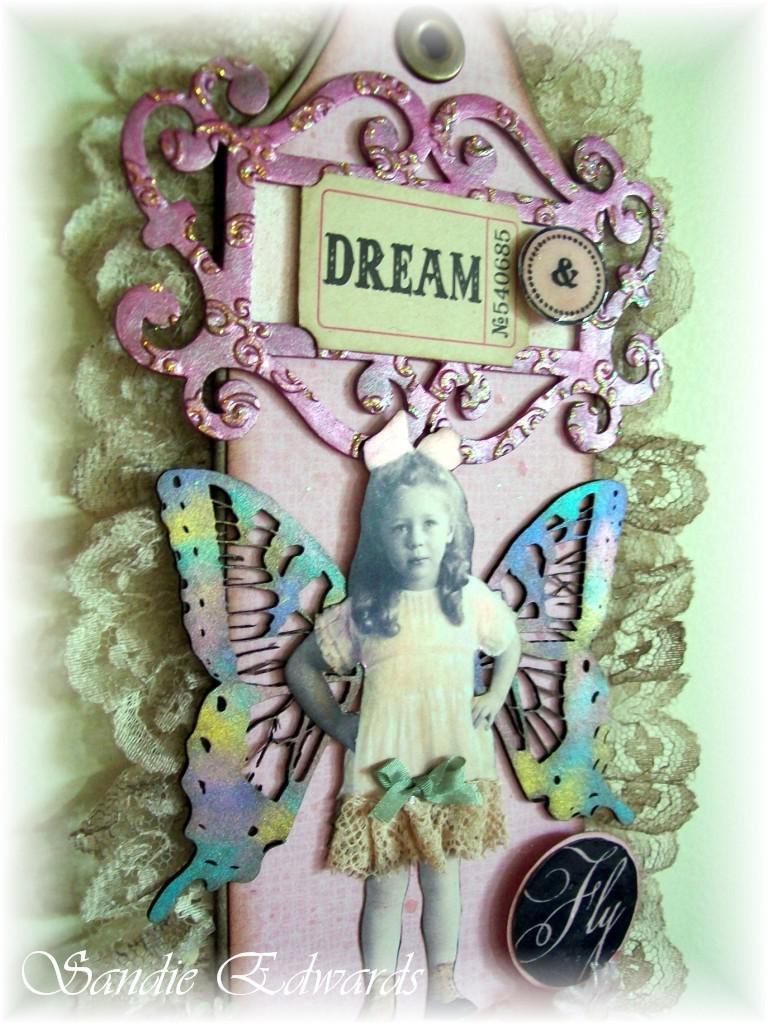Provide a one-sentence caption for the provided image. A piece of artwork featuring a little girl with butterfly wings and the word "dream" written on a ticket stub. 